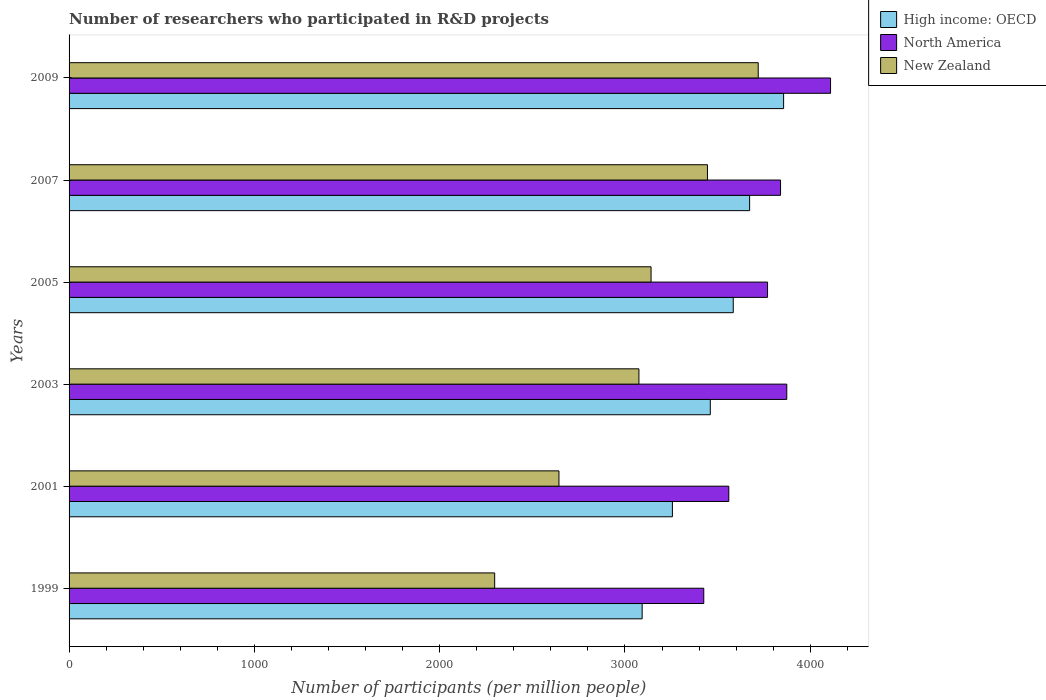How many different coloured bars are there?
Your answer should be compact. 3. How many groups of bars are there?
Your answer should be compact. 6. Are the number of bars per tick equal to the number of legend labels?
Make the answer very short. Yes. How many bars are there on the 6th tick from the bottom?
Offer a very short reply. 3. In how many cases, is the number of bars for a given year not equal to the number of legend labels?
Provide a succinct answer. 0. What is the number of researchers who participated in R&D projects in New Zealand in 2001?
Your answer should be compact. 2643.65. Across all years, what is the maximum number of researchers who participated in R&D projects in New Zealand?
Ensure brevity in your answer.  3719. Across all years, what is the minimum number of researchers who participated in R&D projects in High income: OECD?
Make the answer very short. 3092.68. In which year was the number of researchers who participated in R&D projects in High income: OECD maximum?
Make the answer very short. 2009. In which year was the number of researchers who participated in R&D projects in New Zealand minimum?
Your response must be concise. 1999. What is the total number of researchers who participated in R&D projects in North America in the graph?
Your answer should be compact. 2.26e+04. What is the difference between the number of researchers who participated in R&D projects in New Zealand in 2003 and that in 2009?
Your answer should be very brief. -643.77. What is the difference between the number of researchers who participated in R&D projects in High income: OECD in 2005 and the number of researchers who participated in R&D projects in North America in 2001?
Make the answer very short. 24. What is the average number of researchers who participated in R&D projects in New Zealand per year?
Make the answer very short. 3053.4. In the year 2007, what is the difference between the number of researchers who participated in R&D projects in New Zealand and number of researchers who participated in R&D projects in High income: OECD?
Make the answer very short. -227.63. In how many years, is the number of researchers who participated in R&D projects in North America greater than 1000 ?
Your answer should be very brief. 6. What is the ratio of the number of researchers who participated in R&D projects in New Zealand in 2001 to that in 2003?
Your answer should be compact. 0.86. What is the difference between the highest and the second highest number of researchers who participated in R&D projects in North America?
Offer a terse response. 236.14. What is the difference between the highest and the lowest number of researchers who participated in R&D projects in New Zealand?
Your response must be concise. 1422.2. What does the 3rd bar from the top in 2005 represents?
Your answer should be very brief. High income: OECD. What does the 3rd bar from the bottom in 2005 represents?
Your answer should be compact. New Zealand. Are all the bars in the graph horizontal?
Offer a terse response. Yes. How many years are there in the graph?
Keep it short and to the point. 6. What is the difference between two consecutive major ticks on the X-axis?
Your answer should be very brief. 1000. Does the graph contain grids?
Keep it short and to the point. No. How many legend labels are there?
Keep it short and to the point. 3. What is the title of the graph?
Provide a short and direct response. Number of researchers who participated in R&D projects. Does "Mauritius" appear as one of the legend labels in the graph?
Make the answer very short. No. What is the label or title of the X-axis?
Your response must be concise. Number of participants (per million people). What is the Number of participants (per million people) in High income: OECD in 1999?
Offer a terse response. 3092.68. What is the Number of participants (per million people) of North America in 1999?
Make the answer very short. 3425.18. What is the Number of participants (per million people) of New Zealand in 1999?
Your answer should be compact. 2296.8. What is the Number of participants (per million people) in High income: OECD in 2001?
Provide a succinct answer. 3255.91. What is the Number of participants (per million people) in North America in 2001?
Your answer should be compact. 3560.24. What is the Number of participants (per million people) in New Zealand in 2001?
Make the answer very short. 2643.65. What is the Number of participants (per million people) in High income: OECD in 2003?
Your answer should be compact. 3460.34. What is the Number of participants (per million people) of North America in 2003?
Your response must be concise. 3873.15. What is the Number of participants (per million people) in New Zealand in 2003?
Your answer should be very brief. 3075.22. What is the Number of participants (per million people) of High income: OECD in 2005?
Make the answer very short. 3584.25. What is the Number of participants (per million people) of North America in 2005?
Your answer should be very brief. 3769.29. What is the Number of participants (per million people) in New Zealand in 2005?
Your response must be concise. 3140.74. What is the Number of participants (per million people) in High income: OECD in 2007?
Give a very brief answer. 3672.63. What is the Number of participants (per million people) in North America in 2007?
Your answer should be very brief. 3839.52. What is the Number of participants (per million people) in New Zealand in 2007?
Provide a short and direct response. 3445. What is the Number of participants (per million people) in High income: OECD in 2009?
Keep it short and to the point. 3856. What is the Number of participants (per million people) in North America in 2009?
Provide a short and direct response. 4109.29. What is the Number of participants (per million people) of New Zealand in 2009?
Offer a very short reply. 3719. Across all years, what is the maximum Number of participants (per million people) in High income: OECD?
Keep it short and to the point. 3856. Across all years, what is the maximum Number of participants (per million people) of North America?
Your answer should be very brief. 4109.29. Across all years, what is the maximum Number of participants (per million people) of New Zealand?
Provide a short and direct response. 3719. Across all years, what is the minimum Number of participants (per million people) of High income: OECD?
Offer a very short reply. 3092.68. Across all years, what is the minimum Number of participants (per million people) of North America?
Keep it short and to the point. 3425.18. Across all years, what is the minimum Number of participants (per million people) of New Zealand?
Ensure brevity in your answer.  2296.8. What is the total Number of participants (per million people) in High income: OECD in the graph?
Make the answer very short. 2.09e+04. What is the total Number of participants (per million people) in North America in the graph?
Offer a terse response. 2.26e+04. What is the total Number of participants (per million people) in New Zealand in the graph?
Your answer should be very brief. 1.83e+04. What is the difference between the Number of participants (per million people) of High income: OECD in 1999 and that in 2001?
Your answer should be compact. -163.23. What is the difference between the Number of participants (per million people) in North America in 1999 and that in 2001?
Give a very brief answer. -135.07. What is the difference between the Number of participants (per million people) in New Zealand in 1999 and that in 2001?
Give a very brief answer. -346.85. What is the difference between the Number of participants (per million people) of High income: OECD in 1999 and that in 2003?
Keep it short and to the point. -367.65. What is the difference between the Number of participants (per million people) of North America in 1999 and that in 2003?
Provide a short and direct response. -447.97. What is the difference between the Number of participants (per million people) in New Zealand in 1999 and that in 2003?
Provide a short and direct response. -778.43. What is the difference between the Number of participants (per million people) of High income: OECD in 1999 and that in 2005?
Make the answer very short. -491.56. What is the difference between the Number of participants (per million people) in North America in 1999 and that in 2005?
Offer a very short reply. -344.11. What is the difference between the Number of participants (per million people) in New Zealand in 1999 and that in 2005?
Offer a very short reply. -843.94. What is the difference between the Number of participants (per million people) of High income: OECD in 1999 and that in 2007?
Make the answer very short. -579.95. What is the difference between the Number of participants (per million people) of North America in 1999 and that in 2007?
Provide a succinct answer. -414.35. What is the difference between the Number of participants (per million people) of New Zealand in 1999 and that in 2007?
Offer a very short reply. -1148.21. What is the difference between the Number of participants (per million people) of High income: OECD in 1999 and that in 2009?
Your response must be concise. -763.32. What is the difference between the Number of participants (per million people) in North America in 1999 and that in 2009?
Offer a terse response. -684.12. What is the difference between the Number of participants (per million people) of New Zealand in 1999 and that in 2009?
Offer a very short reply. -1422.2. What is the difference between the Number of participants (per million people) in High income: OECD in 2001 and that in 2003?
Ensure brevity in your answer.  -204.43. What is the difference between the Number of participants (per million people) of North America in 2001 and that in 2003?
Provide a short and direct response. -312.91. What is the difference between the Number of participants (per million people) of New Zealand in 2001 and that in 2003?
Offer a very short reply. -431.58. What is the difference between the Number of participants (per million people) in High income: OECD in 2001 and that in 2005?
Offer a terse response. -328.34. What is the difference between the Number of participants (per million people) in North America in 2001 and that in 2005?
Your response must be concise. -209.05. What is the difference between the Number of participants (per million people) in New Zealand in 2001 and that in 2005?
Provide a succinct answer. -497.09. What is the difference between the Number of participants (per million people) of High income: OECD in 2001 and that in 2007?
Offer a terse response. -416.72. What is the difference between the Number of participants (per million people) of North America in 2001 and that in 2007?
Your answer should be compact. -279.28. What is the difference between the Number of participants (per million people) in New Zealand in 2001 and that in 2007?
Give a very brief answer. -801.36. What is the difference between the Number of participants (per million people) of High income: OECD in 2001 and that in 2009?
Keep it short and to the point. -600.09. What is the difference between the Number of participants (per million people) in North America in 2001 and that in 2009?
Keep it short and to the point. -549.05. What is the difference between the Number of participants (per million people) in New Zealand in 2001 and that in 2009?
Offer a very short reply. -1075.35. What is the difference between the Number of participants (per million people) in High income: OECD in 2003 and that in 2005?
Offer a terse response. -123.91. What is the difference between the Number of participants (per million people) in North America in 2003 and that in 2005?
Your answer should be compact. 103.86. What is the difference between the Number of participants (per million people) of New Zealand in 2003 and that in 2005?
Offer a very short reply. -65.51. What is the difference between the Number of participants (per million people) in High income: OECD in 2003 and that in 2007?
Keep it short and to the point. -212.29. What is the difference between the Number of participants (per million people) of North America in 2003 and that in 2007?
Your answer should be very brief. 33.63. What is the difference between the Number of participants (per million people) of New Zealand in 2003 and that in 2007?
Offer a very short reply. -369.78. What is the difference between the Number of participants (per million people) of High income: OECD in 2003 and that in 2009?
Make the answer very short. -395.66. What is the difference between the Number of participants (per million people) in North America in 2003 and that in 2009?
Ensure brevity in your answer.  -236.14. What is the difference between the Number of participants (per million people) in New Zealand in 2003 and that in 2009?
Your answer should be compact. -643.77. What is the difference between the Number of participants (per million people) in High income: OECD in 2005 and that in 2007?
Give a very brief answer. -88.38. What is the difference between the Number of participants (per million people) of North America in 2005 and that in 2007?
Your response must be concise. -70.23. What is the difference between the Number of participants (per million people) of New Zealand in 2005 and that in 2007?
Make the answer very short. -304.27. What is the difference between the Number of participants (per million people) of High income: OECD in 2005 and that in 2009?
Provide a succinct answer. -271.75. What is the difference between the Number of participants (per million people) in North America in 2005 and that in 2009?
Make the answer very short. -340. What is the difference between the Number of participants (per million people) in New Zealand in 2005 and that in 2009?
Keep it short and to the point. -578.26. What is the difference between the Number of participants (per million people) of High income: OECD in 2007 and that in 2009?
Your answer should be very brief. -183.37. What is the difference between the Number of participants (per million people) of North America in 2007 and that in 2009?
Your answer should be very brief. -269.77. What is the difference between the Number of participants (per million people) in New Zealand in 2007 and that in 2009?
Provide a short and direct response. -273.99. What is the difference between the Number of participants (per million people) of High income: OECD in 1999 and the Number of participants (per million people) of North America in 2001?
Your answer should be very brief. -467.56. What is the difference between the Number of participants (per million people) of High income: OECD in 1999 and the Number of participants (per million people) of New Zealand in 2001?
Your answer should be very brief. 449.04. What is the difference between the Number of participants (per million people) in North America in 1999 and the Number of participants (per million people) in New Zealand in 2001?
Provide a short and direct response. 781.53. What is the difference between the Number of participants (per million people) in High income: OECD in 1999 and the Number of participants (per million people) in North America in 2003?
Make the answer very short. -780.47. What is the difference between the Number of participants (per million people) of High income: OECD in 1999 and the Number of participants (per million people) of New Zealand in 2003?
Offer a very short reply. 17.46. What is the difference between the Number of participants (per million people) in North America in 1999 and the Number of participants (per million people) in New Zealand in 2003?
Ensure brevity in your answer.  349.95. What is the difference between the Number of participants (per million people) in High income: OECD in 1999 and the Number of participants (per million people) in North America in 2005?
Ensure brevity in your answer.  -676.61. What is the difference between the Number of participants (per million people) in High income: OECD in 1999 and the Number of participants (per million people) in New Zealand in 2005?
Ensure brevity in your answer.  -48.05. What is the difference between the Number of participants (per million people) of North America in 1999 and the Number of participants (per million people) of New Zealand in 2005?
Your response must be concise. 284.44. What is the difference between the Number of participants (per million people) of High income: OECD in 1999 and the Number of participants (per million people) of North America in 2007?
Your answer should be compact. -746.84. What is the difference between the Number of participants (per million people) in High income: OECD in 1999 and the Number of participants (per million people) in New Zealand in 2007?
Your answer should be compact. -352.32. What is the difference between the Number of participants (per million people) in North America in 1999 and the Number of participants (per million people) in New Zealand in 2007?
Your answer should be very brief. -19.83. What is the difference between the Number of participants (per million people) in High income: OECD in 1999 and the Number of participants (per million people) in North America in 2009?
Keep it short and to the point. -1016.61. What is the difference between the Number of participants (per million people) in High income: OECD in 1999 and the Number of participants (per million people) in New Zealand in 2009?
Offer a terse response. -626.31. What is the difference between the Number of participants (per million people) in North America in 1999 and the Number of participants (per million people) in New Zealand in 2009?
Offer a very short reply. -293.82. What is the difference between the Number of participants (per million people) of High income: OECD in 2001 and the Number of participants (per million people) of North America in 2003?
Provide a succinct answer. -617.24. What is the difference between the Number of participants (per million people) of High income: OECD in 2001 and the Number of participants (per million people) of New Zealand in 2003?
Your response must be concise. 180.69. What is the difference between the Number of participants (per million people) in North America in 2001 and the Number of participants (per million people) in New Zealand in 2003?
Offer a very short reply. 485.02. What is the difference between the Number of participants (per million people) in High income: OECD in 2001 and the Number of participants (per million people) in North America in 2005?
Give a very brief answer. -513.38. What is the difference between the Number of participants (per million people) in High income: OECD in 2001 and the Number of participants (per million people) in New Zealand in 2005?
Give a very brief answer. 115.18. What is the difference between the Number of participants (per million people) of North America in 2001 and the Number of participants (per million people) of New Zealand in 2005?
Provide a short and direct response. 419.51. What is the difference between the Number of participants (per million people) of High income: OECD in 2001 and the Number of participants (per million people) of North America in 2007?
Your answer should be very brief. -583.61. What is the difference between the Number of participants (per million people) in High income: OECD in 2001 and the Number of participants (per million people) in New Zealand in 2007?
Provide a succinct answer. -189.09. What is the difference between the Number of participants (per million people) of North America in 2001 and the Number of participants (per million people) of New Zealand in 2007?
Provide a short and direct response. 115.24. What is the difference between the Number of participants (per million people) of High income: OECD in 2001 and the Number of participants (per million people) of North America in 2009?
Your answer should be compact. -853.38. What is the difference between the Number of participants (per million people) of High income: OECD in 2001 and the Number of participants (per million people) of New Zealand in 2009?
Provide a succinct answer. -463.09. What is the difference between the Number of participants (per million people) of North America in 2001 and the Number of participants (per million people) of New Zealand in 2009?
Make the answer very short. -158.75. What is the difference between the Number of participants (per million people) in High income: OECD in 2003 and the Number of participants (per million people) in North America in 2005?
Make the answer very short. -308.95. What is the difference between the Number of participants (per million people) in High income: OECD in 2003 and the Number of participants (per million people) in New Zealand in 2005?
Provide a succinct answer. 319.6. What is the difference between the Number of participants (per million people) in North America in 2003 and the Number of participants (per million people) in New Zealand in 2005?
Provide a short and direct response. 732.41. What is the difference between the Number of participants (per million people) in High income: OECD in 2003 and the Number of participants (per million people) in North America in 2007?
Make the answer very short. -379.19. What is the difference between the Number of participants (per million people) in High income: OECD in 2003 and the Number of participants (per million people) in New Zealand in 2007?
Offer a terse response. 15.33. What is the difference between the Number of participants (per million people) in North America in 2003 and the Number of participants (per million people) in New Zealand in 2007?
Offer a terse response. 428.15. What is the difference between the Number of participants (per million people) in High income: OECD in 2003 and the Number of participants (per million people) in North America in 2009?
Offer a terse response. -648.95. What is the difference between the Number of participants (per million people) in High income: OECD in 2003 and the Number of participants (per million people) in New Zealand in 2009?
Offer a terse response. -258.66. What is the difference between the Number of participants (per million people) in North America in 2003 and the Number of participants (per million people) in New Zealand in 2009?
Provide a short and direct response. 154.15. What is the difference between the Number of participants (per million people) in High income: OECD in 2005 and the Number of participants (per million people) in North America in 2007?
Keep it short and to the point. -255.28. What is the difference between the Number of participants (per million people) of High income: OECD in 2005 and the Number of participants (per million people) of New Zealand in 2007?
Your answer should be very brief. 139.24. What is the difference between the Number of participants (per million people) of North America in 2005 and the Number of participants (per million people) of New Zealand in 2007?
Make the answer very short. 324.29. What is the difference between the Number of participants (per million people) of High income: OECD in 2005 and the Number of participants (per million people) of North America in 2009?
Your answer should be compact. -525.04. What is the difference between the Number of participants (per million people) of High income: OECD in 2005 and the Number of participants (per million people) of New Zealand in 2009?
Provide a short and direct response. -134.75. What is the difference between the Number of participants (per million people) of North America in 2005 and the Number of participants (per million people) of New Zealand in 2009?
Give a very brief answer. 50.29. What is the difference between the Number of participants (per million people) in High income: OECD in 2007 and the Number of participants (per million people) in North America in 2009?
Provide a succinct answer. -436.66. What is the difference between the Number of participants (per million people) in High income: OECD in 2007 and the Number of participants (per million people) in New Zealand in 2009?
Offer a very short reply. -46.36. What is the difference between the Number of participants (per million people) in North America in 2007 and the Number of participants (per million people) in New Zealand in 2009?
Offer a very short reply. 120.53. What is the average Number of participants (per million people) of High income: OECD per year?
Your response must be concise. 3486.97. What is the average Number of participants (per million people) of North America per year?
Keep it short and to the point. 3762.78. What is the average Number of participants (per million people) in New Zealand per year?
Offer a terse response. 3053.4. In the year 1999, what is the difference between the Number of participants (per million people) in High income: OECD and Number of participants (per million people) in North America?
Your answer should be very brief. -332.49. In the year 1999, what is the difference between the Number of participants (per million people) in High income: OECD and Number of participants (per million people) in New Zealand?
Make the answer very short. 795.89. In the year 1999, what is the difference between the Number of participants (per million people) in North America and Number of participants (per million people) in New Zealand?
Make the answer very short. 1128.38. In the year 2001, what is the difference between the Number of participants (per million people) in High income: OECD and Number of participants (per million people) in North America?
Your answer should be very brief. -304.33. In the year 2001, what is the difference between the Number of participants (per million people) of High income: OECD and Number of participants (per million people) of New Zealand?
Offer a very short reply. 612.26. In the year 2001, what is the difference between the Number of participants (per million people) in North America and Number of participants (per million people) in New Zealand?
Give a very brief answer. 916.6. In the year 2003, what is the difference between the Number of participants (per million people) of High income: OECD and Number of participants (per million people) of North America?
Your answer should be compact. -412.81. In the year 2003, what is the difference between the Number of participants (per million people) of High income: OECD and Number of participants (per million people) of New Zealand?
Provide a short and direct response. 385.12. In the year 2003, what is the difference between the Number of participants (per million people) in North America and Number of participants (per million people) in New Zealand?
Provide a succinct answer. 797.93. In the year 2005, what is the difference between the Number of participants (per million people) of High income: OECD and Number of participants (per million people) of North America?
Give a very brief answer. -185.04. In the year 2005, what is the difference between the Number of participants (per million people) of High income: OECD and Number of participants (per million people) of New Zealand?
Ensure brevity in your answer.  443.51. In the year 2005, what is the difference between the Number of participants (per million people) in North America and Number of participants (per million people) in New Zealand?
Offer a very short reply. 628.55. In the year 2007, what is the difference between the Number of participants (per million people) of High income: OECD and Number of participants (per million people) of North America?
Ensure brevity in your answer.  -166.89. In the year 2007, what is the difference between the Number of participants (per million people) in High income: OECD and Number of participants (per million people) in New Zealand?
Give a very brief answer. 227.63. In the year 2007, what is the difference between the Number of participants (per million people) of North America and Number of participants (per million people) of New Zealand?
Your answer should be compact. 394.52. In the year 2009, what is the difference between the Number of participants (per million people) of High income: OECD and Number of participants (per million people) of North America?
Offer a very short reply. -253.29. In the year 2009, what is the difference between the Number of participants (per million people) in High income: OECD and Number of participants (per million people) in New Zealand?
Offer a very short reply. 137. In the year 2009, what is the difference between the Number of participants (per million people) in North America and Number of participants (per million people) in New Zealand?
Offer a very short reply. 390.3. What is the ratio of the Number of participants (per million people) in High income: OECD in 1999 to that in 2001?
Make the answer very short. 0.95. What is the ratio of the Number of participants (per million people) in North America in 1999 to that in 2001?
Offer a terse response. 0.96. What is the ratio of the Number of participants (per million people) of New Zealand in 1999 to that in 2001?
Your answer should be very brief. 0.87. What is the ratio of the Number of participants (per million people) in High income: OECD in 1999 to that in 2003?
Your response must be concise. 0.89. What is the ratio of the Number of participants (per million people) in North America in 1999 to that in 2003?
Give a very brief answer. 0.88. What is the ratio of the Number of participants (per million people) in New Zealand in 1999 to that in 2003?
Offer a terse response. 0.75. What is the ratio of the Number of participants (per million people) of High income: OECD in 1999 to that in 2005?
Offer a very short reply. 0.86. What is the ratio of the Number of participants (per million people) of North America in 1999 to that in 2005?
Keep it short and to the point. 0.91. What is the ratio of the Number of participants (per million people) in New Zealand in 1999 to that in 2005?
Offer a very short reply. 0.73. What is the ratio of the Number of participants (per million people) of High income: OECD in 1999 to that in 2007?
Offer a very short reply. 0.84. What is the ratio of the Number of participants (per million people) of North America in 1999 to that in 2007?
Your answer should be compact. 0.89. What is the ratio of the Number of participants (per million people) in High income: OECD in 1999 to that in 2009?
Your answer should be very brief. 0.8. What is the ratio of the Number of participants (per million people) of North America in 1999 to that in 2009?
Offer a terse response. 0.83. What is the ratio of the Number of participants (per million people) in New Zealand in 1999 to that in 2009?
Provide a short and direct response. 0.62. What is the ratio of the Number of participants (per million people) of High income: OECD in 2001 to that in 2003?
Your answer should be very brief. 0.94. What is the ratio of the Number of participants (per million people) in North America in 2001 to that in 2003?
Keep it short and to the point. 0.92. What is the ratio of the Number of participants (per million people) in New Zealand in 2001 to that in 2003?
Give a very brief answer. 0.86. What is the ratio of the Number of participants (per million people) in High income: OECD in 2001 to that in 2005?
Keep it short and to the point. 0.91. What is the ratio of the Number of participants (per million people) in North America in 2001 to that in 2005?
Give a very brief answer. 0.94. What is the ratio of the Number of participants (per million people) of New Zealand in 2001 to that in 2005?
Your response must be concise. 0.84. What is the ratio of the Number of participants (per million people) of High income: OECD in 2001 to that in 2007?
Offer a terse response. 0.89. What is the ratio of the Number of participants (per million people) in North America in 2001 to that in 2007?
Make the answer very short. 0.93. What is the ratio of the Number of participants (per million people) in New Zealand in 2001 to that in 2007?
Make the answer very short. 0.77. What is the ratio of the Number of participants (per million people) in High income: OECD in 2001 to that in 2009?
Offer a terse response. 0.84. What is the ratio of the Number of participants (per million people) in North America in 2001 to that in 2009?
Provide a short and direct response. 0.87. What is the ratio of the Number of participants (per million people) of New Zealand in 2001 to that in 2009?
Make the answer very short. 0.71. What is the ratio of the Number of participants (per million people) in High income: OECD in 2003 to that in 2005?
Provide a short and direct response. 0.97. What is the ratio of the Number of participants (per million people) in North America in 2003 to that in 2005?
Your answer should be very brief. 1.03. What is the ratio of the Number of participants (per million people) of New Zealand in 2003 to that in 2005?
Offer a terse response. 0.98. What is the ratio of the Number of participants (per million people) in High income: OECD in 2003 to that in 2007?
Keep it short and to the point. 0.94. What is the ratio of the Number of participants (per million people) of North America in 2003 to that in 2007?
Offer a terse response. 1.01. What is the ratio of the Number of participants (per million people) in New Zealand in 2003 to that in 2007?
Ensure brevity in your answer.  0.89. What is the ratio of the Number of participants (per million people) of High income: OECD in 2003 to that in 2009?
Your answer should be very brief. 0.9. What is the ratio of the Number of participants (per million people) in North America in 2003 to that in 2009?
Offer a very short reply. 0.94. What is the ratio of the Number of participants (per million people) in New Zealand in 2003 to that in 2009?
Offer a very short reply. 0.83. What is the ratio of the Number of participants (per million people) in High income: OECD in 2005 to that in 2007?
Your answer should be very brief. 0.98. What is the ratio of the Number of participants (per million people) in North America in 2005 to that in 2007?
Your answer should be very brief. 0.98. What is the ratio of the Number of participants (per million people) in New Zealand in 2005 to that in 2007?
Give a very brief answer. 0.91. What is the ratio of the Number of participants (per million people) of High income: OECD in 2005 to that in 2009?
Keep it short and to the point. 0.93. What is the ratio of the Number of participants (per million people) of North America in 2005 to that in 2009?
Offer a very short reply. 0.92. What is the ratio of the Number of participants (per million people) of New Zealand in 2005 to that in 2009?
Provide a short and direct response. 0.84. What is the ratio of the Number of participants (per million people) in North America in 2007 to that in 2009?
Give a very brief answer. 0.93. What is the ratio of the Number of participants (per million people) in New Zealand in 2007 to that in 2009?
Your answer should be very brief. 0.93. What is the difference between the highest and the second highest Number of participants (per million people) of High income: OECD?
Provide a short and direct response. 183.37. What is the difference between the highest and the second highest Number of participants (per million people) of North America?
Ensure brevity in your answer.  236.14. What is the difference between the highest and the second highest Number of participants (per million people) of New Zealand?
Your answer should be compact. 273.99. What is the difference between the highest and the lowest Number of participants (per million people) in High income: OECD?
Give a very brief answer. 763.32. What is the difference between the highest and the lowest Number of participants (per million people) of North America?
Provide a succinct answer. 684.12. What is the difference between the highest and the lowest Number of participants (per million people) in New Zealand?
Provide a succinct answer. 1422.2. 